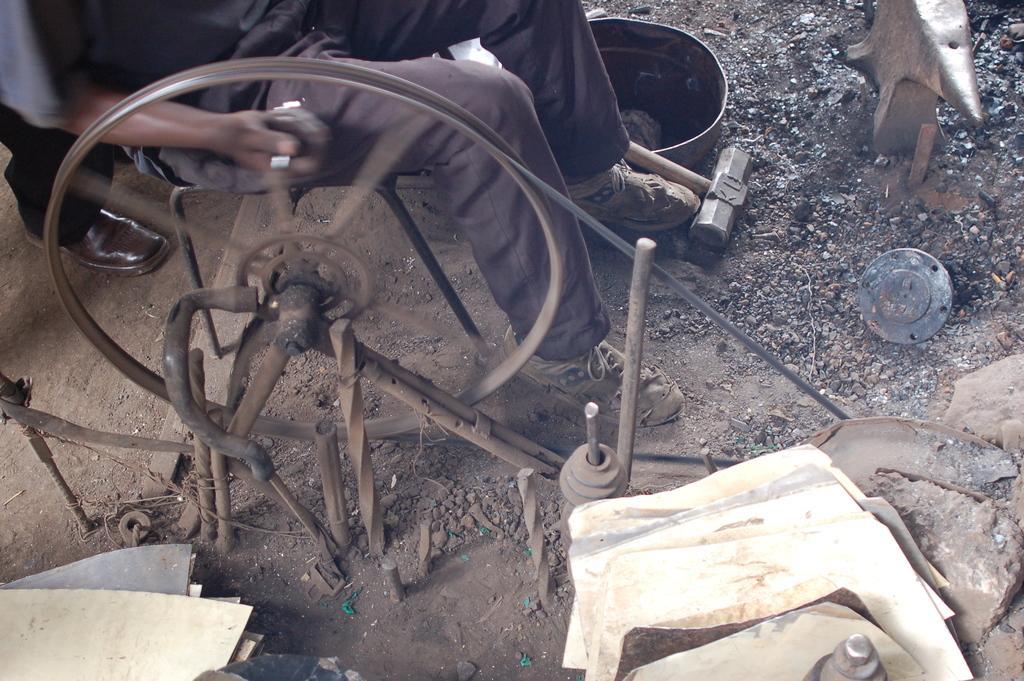In one or two sentences, can you explain what this image depicts? There is a person who is sitting on a chair and holding handle of a wheel, near some iron objects. In the background, there is a person who is standing on the ground and there are other objects. 